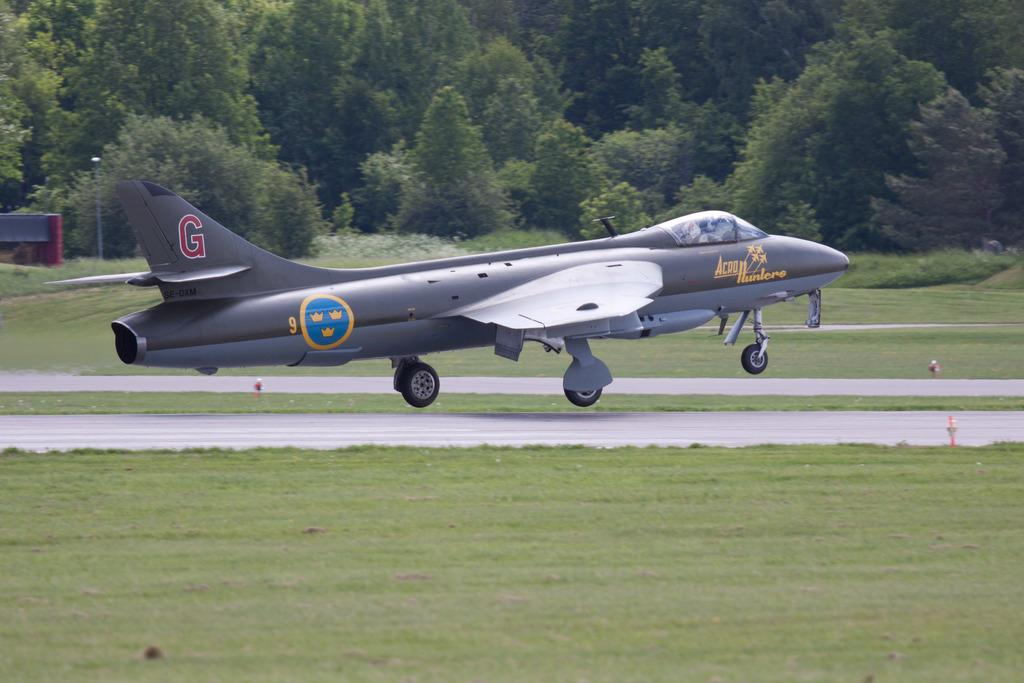<image>
Write a terse but informative summary of the picture. A small military jet marked Acro Hunters is landing or taking off. 